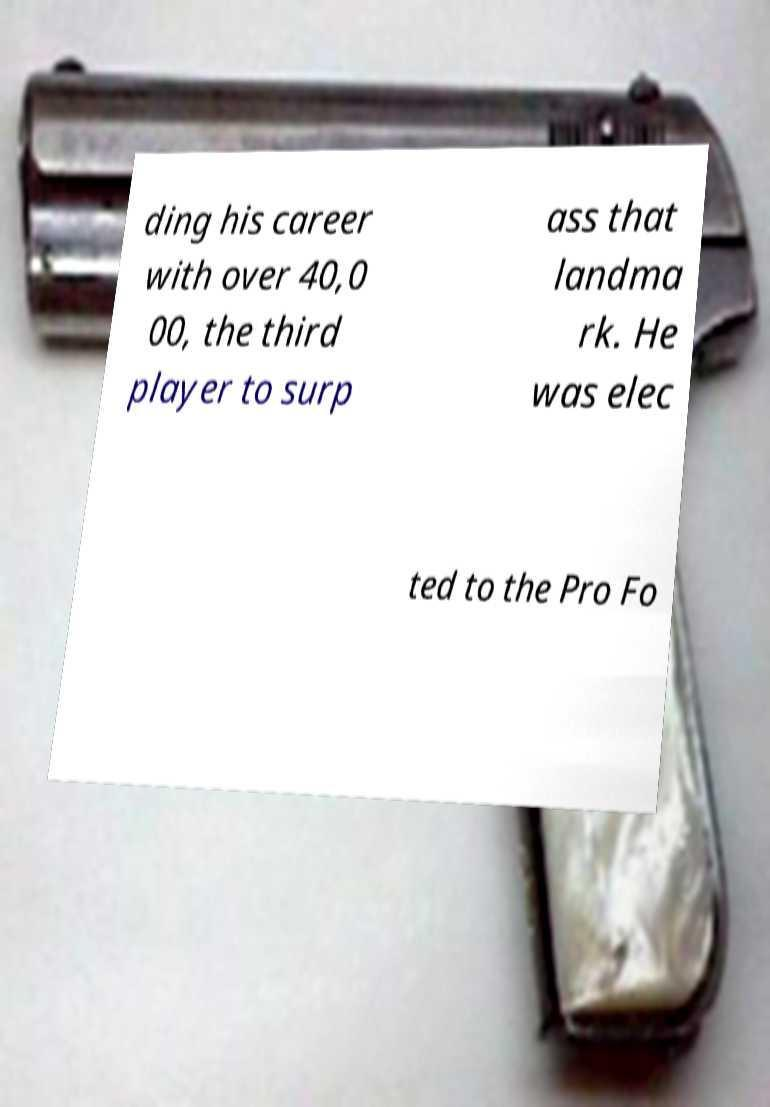Can you read and provide the text displayed in the image?This photo seems to have some interesting text. Can you extract and type it out for me? ding his career with over 40,0 00, the third player to surp ass that landma rk. He was elec ted to the Pro Fo 